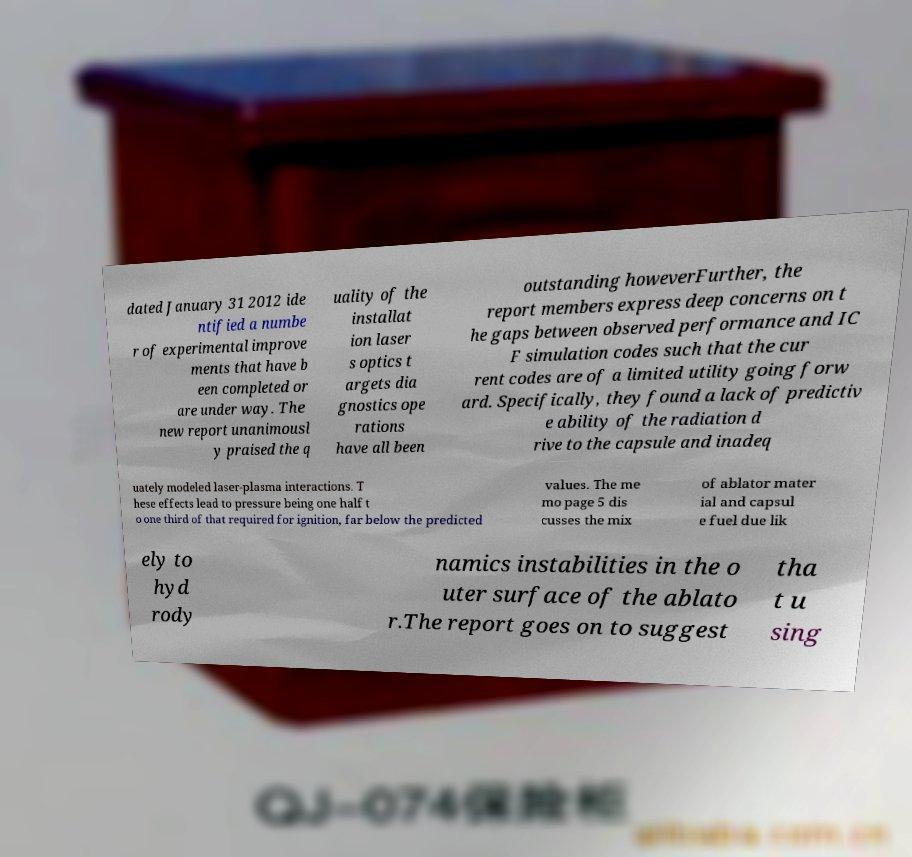There's text embedded in this image that I need extracted. Can you transcribe it verbatim? dated January 31 2012 ide ntified a numbe r of experimental improve ments that have b een completed or are under way. The new report unanimousl y praised the q uality of the installat ion laser s optics t argets dia gnostics ope rations have all been outstanding howeverFurther, the report members express deep concerns on t he gaps between observed performance and IC F simulation codes such that the cur rent codes are of a limited utility going forw ard. Specifically, they found a lack of predictiv e ability of the radiation d rive to the capsule and inadeq uately modeled laser-plasma interactions. T hese effects lead to pressure being one half t o one third of that required for ignition, far below the predicted values. The me mo page 5 dis cusses the mix of ablator mater ial and capsul e fuel due lik ely to hyd rody namics instabilities in the o uter surface of the ablato r.The report goes on to suggest tha t u sing 